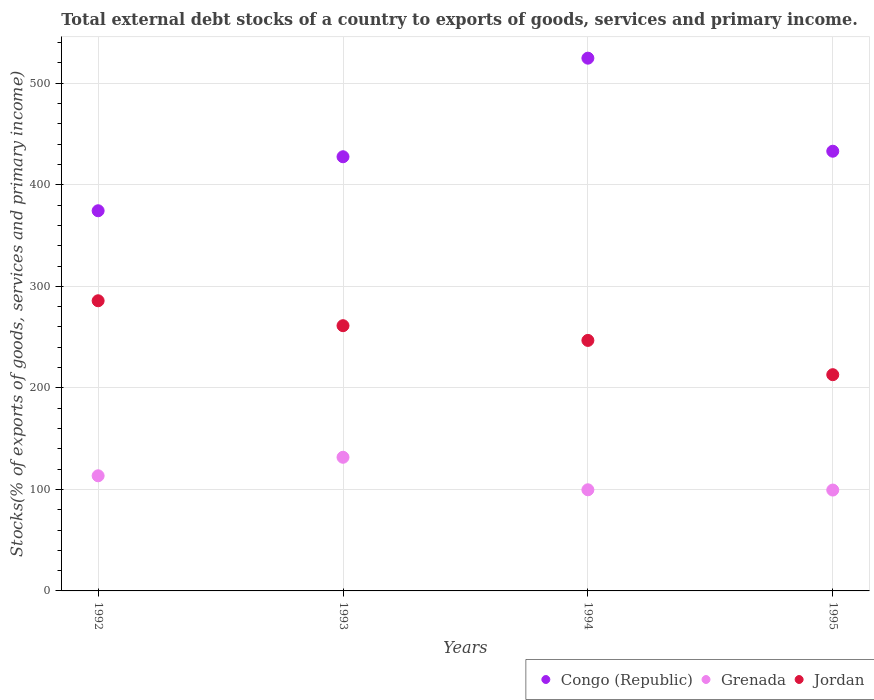How many different coloured dotlines are there?
Your answer should be very brief. 3. What is the total debt stocks in Congo (Republic) in 1993?
Make the answer very short. 427.65. Across all years, what is the maximum total debt stocks in Grenada?
Give a very brief answer. 131.63. Across all years, what is the minimum total debt stocks in Jordan?
Your answer should be very brief. 212.98. What is the total total debt stocks in Congo (Republic) in the graph?
Provide a short and direct response. 1759.95. What is the difference between the total debt stocks in Grenada in 1994 and that in 1995?
Make the answer very short. 0.26. What is the difference between the total debt stocks in Jordan in 1994 and the total debt stocks in Grenada in 1995?
Make the answer very short. 147.39. What is the average total debt stocks in Jordan per year?
Provide a short and direct response. 251.69. In the year 1994, what is the difference between the total debt stocks in Congo (Republic) and total debt stocks in Jordan?
Ensure brevity in your answer.  278.01. In how many years, is the total debt stocks in Congo (Republic) greater than 180 %?
Give a very brief answer. 4. What is the ratio of the total debt stocks in Congo (Republic) in 1994 to that in 1995?
Keep it short and to the point. 1.21. Is the total debt stocks in Congo (Republic) in 1992 less than that in 1994?
Your answer should be compact. Yes. What is the difference between the highest and the second highest total debt stocks in Congo (Republic)?
Your response must be concise. 91.65. What is the difference between the highest and the lowest total debt stocks in Grenada?
Provide a succinct answer. 32.28. Is it the case that in every year, the sum of the total debt stocks in Grenada and total debt stocks in Congo (Republic)  is greater than the total debt stocks in Jordan?
Your response must be concise. Yes. Does the total debt stocks in Grenada monotonically increase over the years?
Your answer should be compact. No. Is the total debt stocks in Jordan strictly greater than the total debt stocks in Grenada over the years?
Provide a short and direct response. Yes. How many years are there in the graph?
Keep it short and to the point. 4. Does the graph contain any zero values?
Provide a short and direct response. No. Does the graph contain grids?
Offer a very short reply. Yes. Where does the legend appear in the graph?
Offer a terse response. Bottom right. How are the legend labels stacked?
Keep it short and to the point. Horizontal. What is the title of the graph?
Keep it short and to the point. Total external debt stocks of a country to exports of goods, services and primary income. Does "Belize" appear as one of the legend labels in the graph?
Ensure brevity in your answer.  No. What is the label or title of the Y-axis?
Provide a short and direct response. Stocks(% of exports of goods, services and primary income). What is the Stocks(% of exports of goods, services and primary income) in Congo (Republic) in 1992?
Offer a very short reply. 374.45. What is the Stocks(% of exports of goods, services and primary income) in Grenada in 1992?
Your answer should be compact. 113.4. What is the Stocks(% of exports of goods, services and primary income) of Jordan in 1992?
Give a very brief answer. 285.8. What is the Stocks(% of exports of goods, services and primary income) of Congo (Republic) in 1993?
Give a very brief answer. 427.65. What is the Stocks(% of exports of goods, services and primary income) of Grenada in 1993?
Your answer should be compact. 131.63. What is the Stocks(% of exports of goods, services and primary income) of Jordan in 1993?
Ensure brevity in your answer.  261.25. What is the Stocks(% of exports of goods, services and primary income) in Congo (Republic) in 1994?
Provide a succinct answer. 524.75. What is the Stocks(% of exports of goods, services and primary income) of Grenada in 1994?
Your answer should be compact. 99.61. What is the Stocks(% of exports of goods, services and primary income) of Jordan in 1994?
Your answer should be compact. 246.74. What is the Stocks(% of exports of goods, services and primary income) in Congo (Republic) in 1995?
Offer a terse response. 433.09. What is the Stocks(% of exports of goods, services and primary income) of Grenada in 1995?
Your response must be concise. 99.35. What is the Stocks(% of exports of goods, services and primary income) in Jordan in 1995?
Make the answer very short. 212.98. Across all years, what is the maximum Stocks(% of exports of goods, services and primary income) in Congo (Republic)?
Provide a short and direct response. 524.75. Across all years, what is the maximum Stocks(% of exports of goods, services and primary income) of Grenada?
Provide a succinct answer. 131.63. Across all years, what is the maximum Stocks(% of exports of goods, services and primary income) in Jordan?
Ensure brevity in your answer.  285.8. Across all years, what is the minimum Stocks(% of exports of goods, services and primary income) of Congo (Republic)?
Your response must be concise. 374.45. Across all years, what is the minimum Stocks(% of exports of goods, services and primary income) in Grenada?
Ensure brevity in your answer.  99.35. Across all years, what is the minimum Stocks(% of exports of goods, services and primary income) of Jordan?
Make the answer very short. 212.98. What is the total Stocks(% of exports of goods, services and primary income) in Congo (Republic) in the graph?
Your answer should be compact. 1759.95. What is the total Stocks(% of exports of goods, services and primary income) in Grenada in the graph?
Your answer should be very brief. 444. What is the total Stocks(% of exports of goods, services and primary income) of Jordan in the graph?
Ensure brevity in your answer.  1006.77. What is the difference between the Stocks(% of exports of goods, services and primary income) in Congo (Republic) in 1992 and that in 1993?
Keep it short and to the point. -53.2. What is the difference between the Stocks(% of exports of goods, services and primary income) of Grenada in 1992 and that in 1993?
Make the answer very short. -18.23. What is the difference between the Stocks(% of exports of goods, services and primary income) of Jordan in 1992 and that in 1993?
Give a very brief answer. 24.55. What is the difference between the Stocks(% of exports of goods, services and primary income) in Congo (Republic) in 1992 and that in 1994?
Your response must be concise. -150.29. What is the difference between the Stocks(% of exports of goods, services and primary income) in Grenada in 1992 and that in 1994?
Your answer should be compact. 13.79. What is the difference between the Stocks(% of exports of goods, services and primary income) of Jordan in 1992 and that in 1994?
Give a very brief answer. 39.05. What is the difference between the Stocks(% of exports of goods, services and primary income) of Congo (Republic) in 1992 and that in 1995?
Make the answer very short. -58.64. What is the difference between the Stocks(% of exports of goods, services and primary income) of Grenada in 1992 and that in 1995?
Offer a very short reply. 14.05. What is the difference between the Stocks(% of exports of goods, services and primary income) in Jordan in 1992 and that in 1995?
Offer a very short reply. 72.81. What is the difference between the Stocks(% of exports of goods, services and primary income) of Congo (Republic) in 1993 and that in 1994?
Ensure brevity in your answer.  -97.1. What is the difference between the Stocks(% of exports of goods, services and primary income) in Grenada in 1993 and that in 1994?
Keep it short and to the point. 32.02. What is the difference between the Stocks(% of exports of goods, services and primary income) in Jordan in 1993 and that in 1994?
Provide a short and direct response. 14.51. What is the difference between the Stocks(% of exports of goods, services and primary income) in Congo (Republic) in 1993 and that in 1995?
Offer a terse response. -5.44. What is the difference between the Stocks(% of exports of goods, services and primary income) in Grenada in 1993 and that in 1995?
Provide a succinct answer. 32.28. What is the difference between the Stocks(% of exports of goods, services and primary income) in Jordan in 1993 and that in 1995?
Provide a succinct answer. 48.27. What is the difference between the Stocks(% of exports of goods, services and primary income) in Congo (Republic) in 1994 and that in 1995?
Ensure brevity in your answer.  91.65. What is the difference between the Stocks(% of exports of goods, services and primary income) of Grenada in 1994 and that in 1995?
Your response must be concise. 0.26. What is the difference between the Stocks(% of exports of goods, services and primary income) of Jordan in 1994 and that in 1995?
Your answer should be compact. 33.76. What is the difference between the Stocks(% of exports of goods, services and primary income) of Congo (Republic) in 1992 and the Stocks(% of exports of goods, services and primary income) of Grenada in 1993?
Provide a short and direct response. 242.82. What is the difference between the Stocks(% of exports of goods, services and primary income) of Congo (Republic) in 1992 and the Stocks(% of exports of goods, services and primary income) of Jordan in 1993?
Make the answer very short. 113.21. What is the difference between the Stocks(% of exports of goods, services and primary income) in Grenada in 1992 and the Stocks(% of exports of goods, services and primary income) in Jordan in 1993?
Ensure brevity in your answer.  -147.85. What is the difference between the Stocks(% of exports of goods, services and primary income) in Congo (Republic) in 1992 and the Stocks(% of exports of goods, services and primary income) in Grenada in 1994?
Your response must be concise. 274.84. What is the difference between the Stocks(% of exports of goods, services and primary income) in Congo (Republic) in 1992 and the Stocks(% of exports of goods, services and primary income) in Jordan in 1994?
Provide a short and direct response. 127.71. What is the difference between the Stocks(% of exports of goods, services and primary income) in Grenada in 1992 and the Stocks(% of exports of goods, services and primary income) in Jordan in 1994?
Your answer should be compact. -133.34. What is the difference between the Stocks(% of exports of goods, services and primary income) in Congo (Republic) in 1992 and the Stocks(% of exports of goods, services and primary income) in Grenada in 1995?
Keep it short and to the point. 275.1. What is the difference between the Stocks(% of exports of goods, services and primary income) in Congo (Republic) in 1992 and the Stocks(% of exports of goods, services and primary income) in Jordan in 1995?
Offer a terse response. 161.47. What is the difference between the Stocks(% of exports of goods, services and primary income) in Grenada in 1992 and the Stocks(% of exports of goods, services and primary income) in Jordan in 1995?
Give a very brief answer. -99.58. What is the difference between the Stocks(% of exports of goods, services and primary income) in Congo (Republic) in 1993 and the Stocks(% of exports of goods, services and primary income) in Grenada in 1994?
Your answer should be compact. 328.04. What is the difference between the Stocks(% of exports of goods, services and primary income) in Congo (Republic) in 1993 and the Stocks(% of exports of goods, services and primary income) in Jordan in 1994?
Make the answer very short. 180.91. What is the difference between the Stocks(% of exports of goods, services and primary income) in Grenada in 1993 and the Stocks(% of exports of goods, services and primary income) in Jordan in 1994?
Your answer should be very brief. -115.11. What is the difference between the Stocks(% of exports of goods, services and primary income) of Congo (Republic) in 1993 and the Stocks(% of exports of goods, services and primary income) of Grenada in 1995?
Offer a terse response. 328.3. What is the difference between the Stocks(% of exports of goods, services and primary income) of Congo (Republic) in 1993 and the Stocks(% of exports of goods, services and primary income) of Jordan in 1995?
Make the answer very short. 214.67. What is the difference between the Stocks(% of exports of goods, services and primary income) of Grenada in 1993 and the Stocks(% of exports of goods, services and primary income) of Jordan in 1995?
Make the answer very short. -81.35. What is the difference between the Stocks(% of exports of goods, services and primary income) in Congo (Republic) in 1994 and the Stocks(% of exports of goods, services and primary income) in Grenada in 1995?
Make the answer very short. 425.39. What is the difference between the Stocks(% of exports of goods, services and primary income) in Congo (Republic) in 1994 and the Stocks(% of exports of goods, services and primary income) in Jordan in 1995?
Provide a short and direct response. 311.77. What is the difference between the Stocks(% of exports of goods, services and primary income) of Grenada in 1994 and the Stocks(% of exports of goods, services and primary income) of Jordan in 1995?
Offer a terse response. -113.37. What is the average Stocks(% of exports of goods, services and primary income) in Congo (Republic) per year?
Offer a terse response. 439.99. What is the average Stocks(% of exports of goods, services and primary income) in Grenada per year?
Make the answer very short. 111. What is the average Stocks(% of exports of goods, services and primary income) of Jordan per year?
Offer a very short reply. 251.69. In the year 1992, what is the difference between the Stocks(% of exports of goods, services and primary income) in Congo (Republic) and Stocks(% of exports of goods, services and primary income) in Grenada?
Make the answer very short. 261.05. In the year 1992, what is the difference between the Stocks(% of exports of goods, services and primary income) in Congo (Republic) and Stocks(% of exports of goods, services and primary income) in Jordan?
Give a very brief answer. 88.66. In the year 1992, what is the difference between the Stocks(% of exports of goods, services and primary income) in Grenada and Stocks(% of exports of goods, services and primary income) in Jordan?
Offer a very short reply. -172.4. In the year 1993, what is the difference between the Stocks(% of exports of goods, services and primary income) in Congo (Republic) and Stocks(% of exports of goods, services and primary income) in Grenada?
Offer a very short reply. 296.02. In the year 1993, what is the difference between the Stocks(% of exports of goods, services and primary income) in Congo (Republic) and Stocks(% of exports of goods, services and primary income) in Jordan?
Your answer should be very brief. 166.4. In the year 1993, what is the difference between the Stocks(% of exports of goods, services and primary income) of Grenada and Stocks(% of exports of goods, services and primary income) of Jordan?
Provide a succinct answer. -129.61. In the year 1994, what is the difference between the Stocks(% of exports of goods, services and primary income) of Congo (Republic) and Stocks(% of exports of goods, services and primary income) of Grenada?
Keep it short and to the point. 425.13. In the year 1994, what is the difference between the Stocks(% of exports of goods, services and primary income) in Congo (Republic) and Stocks(% of exports of goods, services and primary income) in Jordan?
Offer a terse response. 278.01. In the year 1994, what is the difference between the Stocks(% of exports of goods, services and primary income) of Grenada and Stocks(% of exports of goods, services and primary income) of Jordan?
Your answer should be very brief. -147.13. In the year 1995, what is the difference between the Stocks(% of exports of goods, services and primary income) in Congo (Republic) and Stocks(% of exports of goods, services and primary income) in Grenada?
Your answer should be very brief. 333.74. In the year 1995, what is the difference between the Stocks(% of exports of goods, services and primary income) in Congo (Republic) and Stocks(% of exports of goods, services and primary income) in Jordan?
Ensure brevity in your answer.  220.11. In the year 1995, what is the difference between the Stocks(% of exports of goods, services and primary income) in Grenada and Stocks(% of exports of goods, services and primary income) in Jordan?
Make the answer very short. -113.63. What is the ratio of the Stocks(% of exports of goods, services and primary income) in Congo (Republic) in 1992 to that in 1993?
Offer a very short reply. 0.88. What is the ratio of the Stocks(% of exports of goods, services and primary income) of Grenada in 1992 to that in 1993?
Provide a succinct answer. 0.86. What is the ratio of the Stocks(% of exports of goods, services and primary income) of Jordan in 1992 to that in 1993?
Ensure brevity in your answer.  1.09. What is the ratio of the Stocks(% of exports of goods, services and primary income) in Congo (Republic) in 1992 to that in 1994?
Make the answer very short. 0.71. What is the ratio of the Stocks(% of exports of goods, services and primary income) of Grenada in 1992 to that in 1994?
Offer a very short reply. 1.14. What is the ratio of the Stocks(% of exports of goods, services and primary income) in Jordan in 1992 to that in 1994?
Keep it short and to the point. 1.16. What is the ratio of the Stocks(% of exports of goods, services and primary income) of Congo (Republic) in 1992 to that in 1995?
Give a very brief answer. 0.86. What is the ratio of the Stocks(% of exports of goods, services and primary income) of Grenada in 1992 to that in 1995?
Your answer should be compact. 1.14. What is the ratio of the Stocks(% of exports of goods, services and primary income) of Jordan in 1992 to that in 1995?
Provide a short and direct response. 1.34. What is the ratio of the Stocks(% of exports of goods, services and primary income) of Congo (Republic) in 1993 to that in 1994?
Your response must be concise. 0.81. What is the ratio of the Stocks(% of exports of goods, services and primary income) in Grenada in 1993 to that in 1994?
Your answer should be compact. 1.32. What is the ratio of the Stocks(% of exports of goods, services and primary income) in Jordan in 1993 to that in 1994?
Provide a short and direct response. 1.06. What is the ratio of the Stocks(% of exports of goods, services and primary income) of Congo (Republic) in 1993 to that in 1995?
Provide a short and direct response. 0.99. What is the ratio of the Stocks(% of exports of goods, services and primary income) in Grenada in 1993 to that in 1995?
Make the answer very short. 1.32. What is the ratio of the Stocks(% of exports of goods, services and primary income) of Jordan in 1993 to that in 1995?
Your response must be concise. 1.23. What is the ratio of the Stocks(% of exports of goods, services and primary income) in Congo (Republic) in 1994 to that in 1995?
Ensure brevity in your answer.  1.21. What is the ratio of the Stocks(% of exports of goods, services and primary income) in Jordan in 1994 to that in 1995?
Offer a terse response. 1.16. What is the difference between the highest and the second highest Stocks(% of exports of goods, services and primary income) of Congo (Republic)?
Your answer should be very brief. 91.65. What is the difference between the highest and the second highest Stocks(% of exports of goods, services and primary income) in Grenada?
Keep it short and to the point. 18.23. What is the difference between the highest and the second highest Stocks(% of exports of goods, services and primary income) of Jordan?
Ensure brevity in your answer.  24.55. What is the difference between the highest and the lowest Stocks(% of exports of goods, services and primary income) of Congo (Republic)?
Keep it short and to the point. 150.29. What is the difference between the highest and the lowest Stocks(% of exports of goods, services and primary income) of Grenada?
Keep it short and to the point. 32.28. What is the difference between the highest and the lowest Stocks(% of exports of goods, services and primary income) of Jordan?
Offer a very short reply. 72.81. 